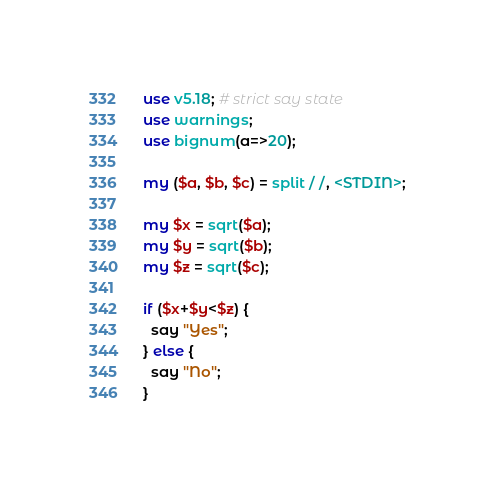Convert code to text. <code><loc_0><loc_0><loc_500><loc_500><_Perl_>use v5.18; # strict say state
use warnings;
use bignum(a=>20);

my ($a, $b, $c) = split / /, <STDIN>;

my $x = sqrt($a);
my $y = sqrt($b);
my $z = sqrt($c);

if ($x+$y<$z) {
  say "Yes";
} else {
  say "No";
}</code> 